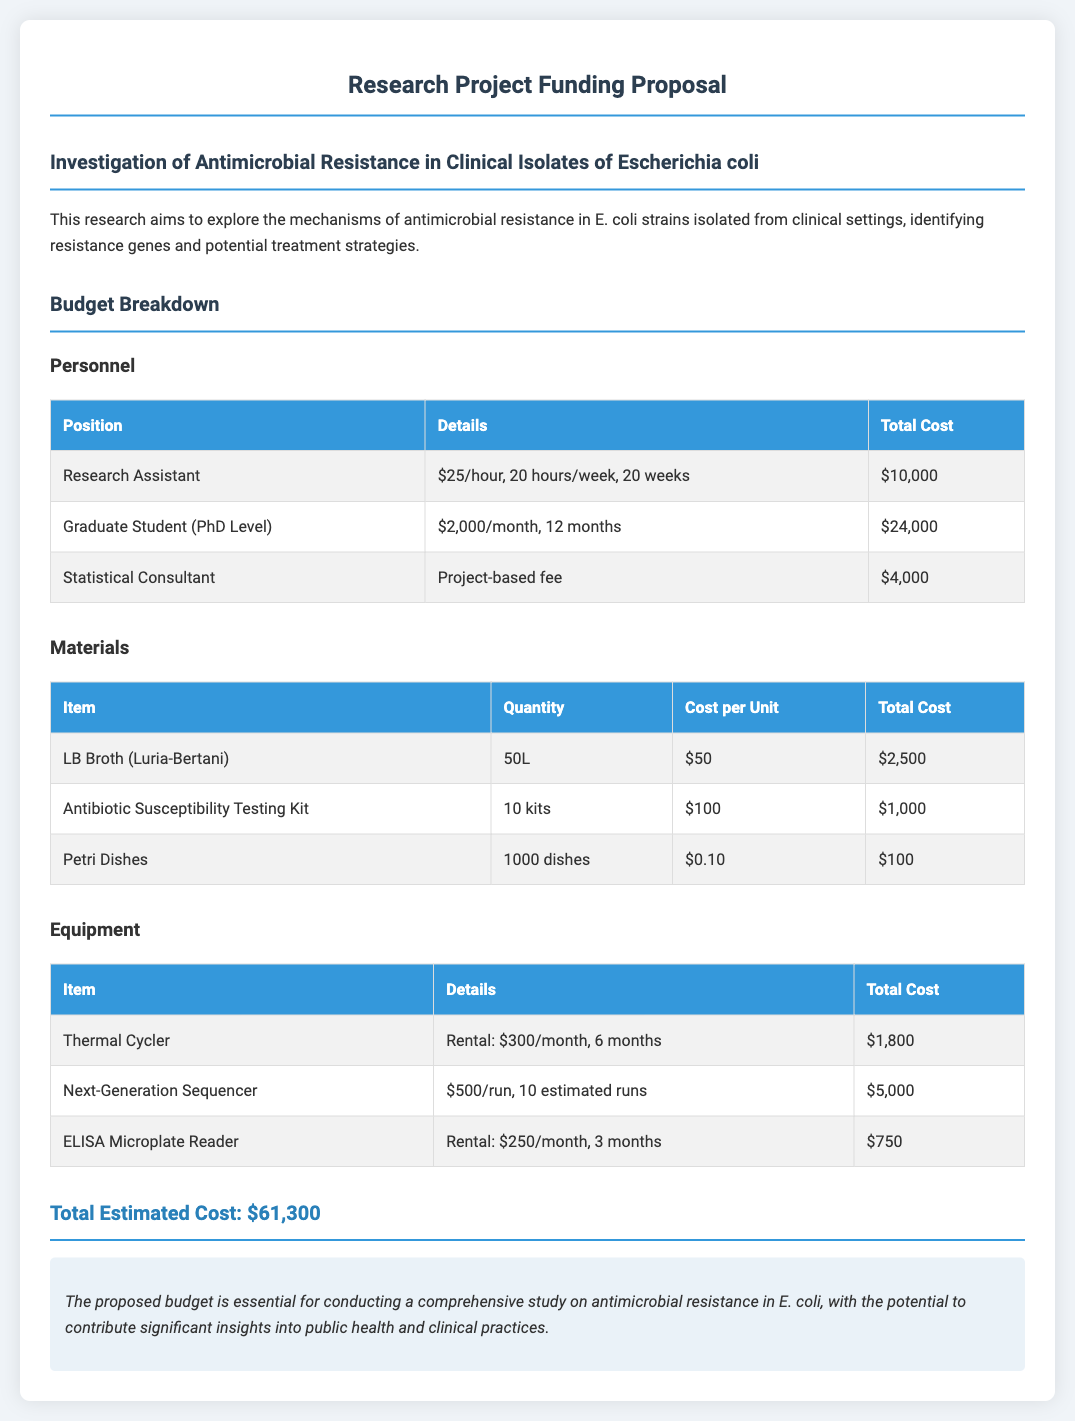What is the total estimated cost? The total estimated cost is the sum of all expenses listed in the budget, which equals $61,300.
Answer: $61,300 How much is allocated for the Research Assistant? The cost for the Research Assistant can be found in the Personnel section, which states $10,000.
Answer: $10,000 What is the quantity of LB Broth needed? The quantity of LB Broth is specified in the Materials section, which lists 50L.
Answer: 50L What is the rental cost for the Thermal Cycler? The rental cost for the Thermal Cycler is mentioned in the Equipment table, which is $300/month for 6 months totaling to $1,800.
Answer: $1,800 How many Petri Dishes are required? The number of Petri Dishes required is shown in the Materials section, which states 1000 dishes.
Answer: 1000 dishes What is the monthly cost for the Graduate Student? The document notes that the Graduate Student is paid $2,000 per month as per the Personnel section.
Answer: $2,000 How many estimated runs are there for the Next-Generation Sequencer? The document indicates in the Equipment section that there are 10 estimated runs for the sequencer.
Answer: 10 runs What is the total cost of the Antibiotic Susceptibility Testing Kit? The total cost for the Antibiotic Susceptibility Testing Kit is specified in the Materials section, which is $1,000 for 10 kits.
Answer: $1,000 